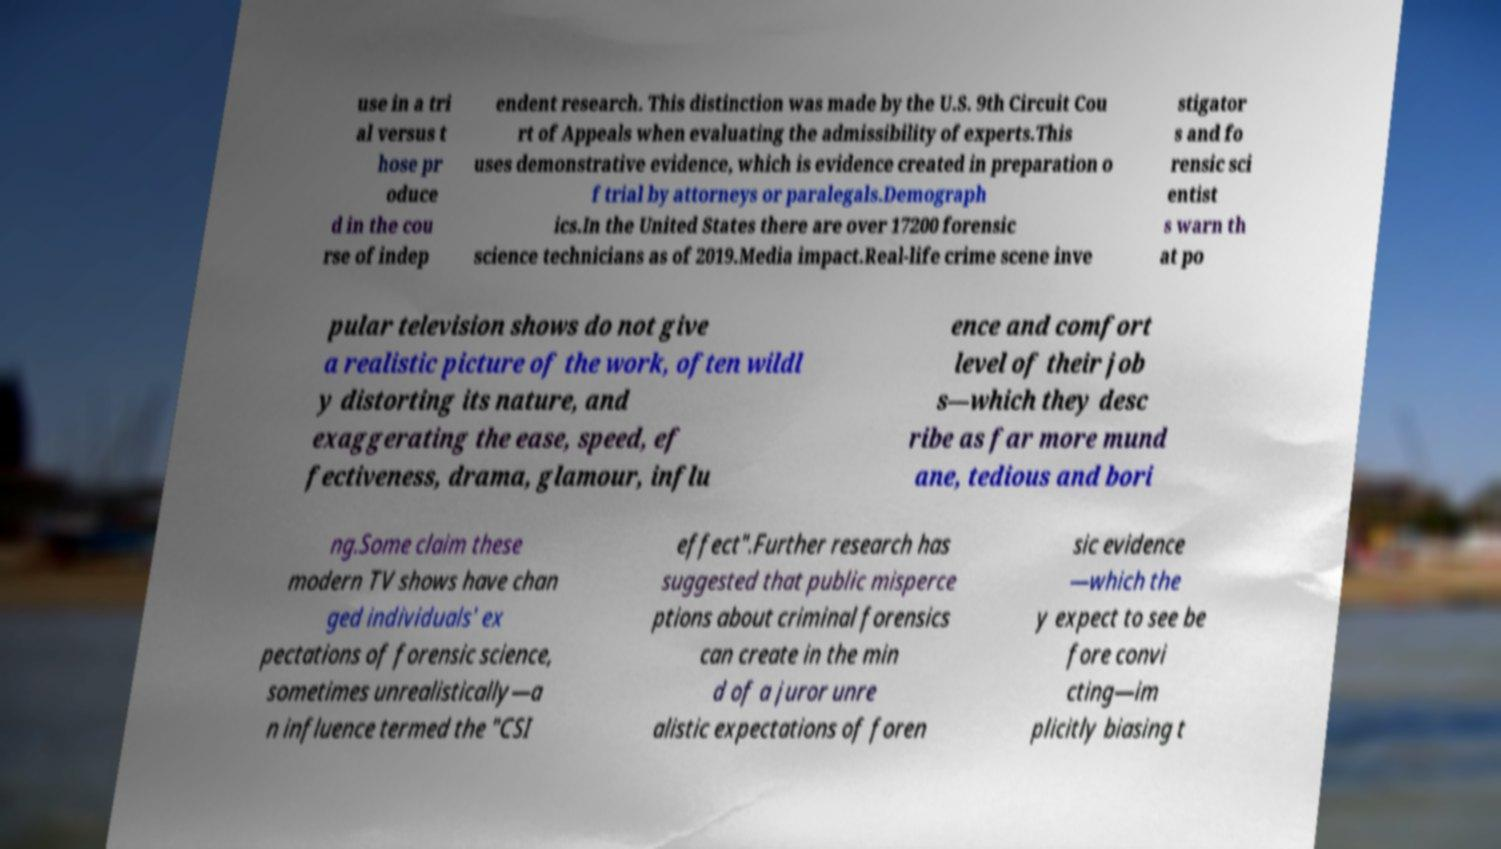Please read and relay the text visible in this image. What does it say? use in a tri al versus t hose pr oduce d in the cou rse of indep endent research. This distinction was made by the U.S. 9th Circuit Cou rt of Appeals when evaluating the admissibility of experts.This uses demonstrative evidence, which is evidence created in preparation o f trial by attorneys or paralegals.Demograph ics.In the United States there are over 17200 forensic science technicians as of 2019.Media impact.Real-life crime scene inve stigator s and fo rensic sci entist s warn th at po pular television shows do not give a realistic picture of the work, often wildl y distorting its nature, and exaggerating the ease, speed, ef fectiveness, drama, glamour, influ ence and comfort level of their job s—which they desc ribe as far more mund ane, tedious and bori ng.Some claim these modern TV shows have chan ged individuals' ex pectations of forensic science, sometimes unrealistically—a n influence termed the "CSI effect".Further research has suggested that public misperce ptions about criminal forensics can create in the min d of a juror unre alistic expectations of foren sic evidence —which the y expect to see be fore convi cting—im plicitly biasing t 